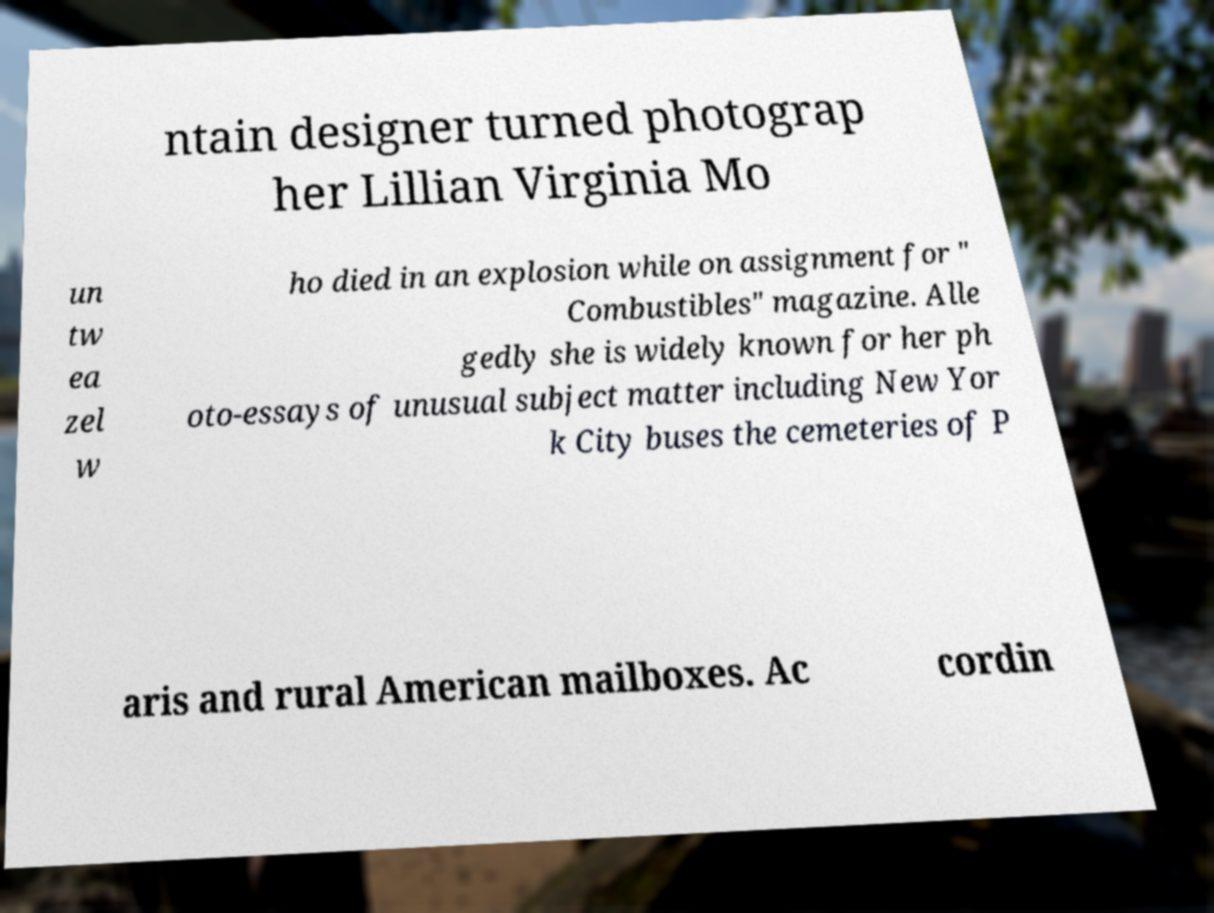Can you accurately transcribe the text from the provided image for me? ntain designer turned photograp her Lillian Virginia Mo un tw ea zel w ho died in an explosion while on assignment for " Combustibles" magazine. Alle gedly she is widely known for her ph oto-essays of unusual subject matter including New Yor k City buses the cemeteries of P aris and rural American mailboxes. Ac cordin 